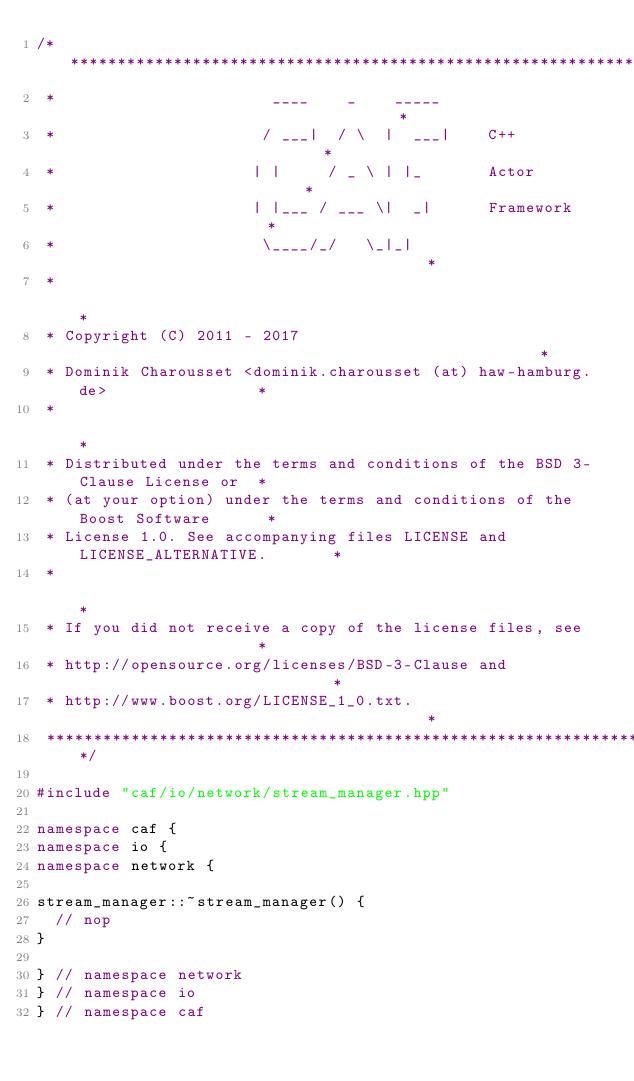<code> <loc_0><loc_0><loc_500><loc_500><_C++_>/******************************************************************************
 *                       ____    _    _____                                   *
 *                      / ___|  / \  |  ___|    C++                           *
 *                     | |     / _ \ | |_       Actor                         *
 *                     | |___ / ___ \|  _|      Framework                     *
 *                      \____/_/   \_|_|                                      *
 *                                                                            *
 * Copyright (C) 2011 - 2017                                                  *
 * Dominik Charousset <dominik.charousset (at) haw-hamburg.de>                *
 *                                                                            *
 * Distributed under the terms and conditions of the BSD 3-Clause License or  *
 * (at your option) under the terms and conditions of the Boost Software      *
 * License 1.0. See accompanying files LICENSE and LICENSE_ALTERNATIVE.       *
 *                                                                            *
 * If you did not receive a copy of the license files, see                    *
 * http://opensource.org/licenses/BSD-3-Clause and                            *
 * http://www.boost.org/LICENSE_1_0.txt.                                      *
 ******************************************************************************/

#include "caf/io/network/stream_manager.hpp"

namespace caf {
namespace io {
namespace network {

stream_manager::~stream_manager() {
  // nop
}

} // namespace network
} // namespace io
} // namespace caf
</code> 